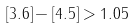Convert formula to latex. <formula><loc_0><loc_0><loc_500><loc_500>[ 3 . 6 ] - [ 4 . 5 ] > 1 . 0 5</formula> 